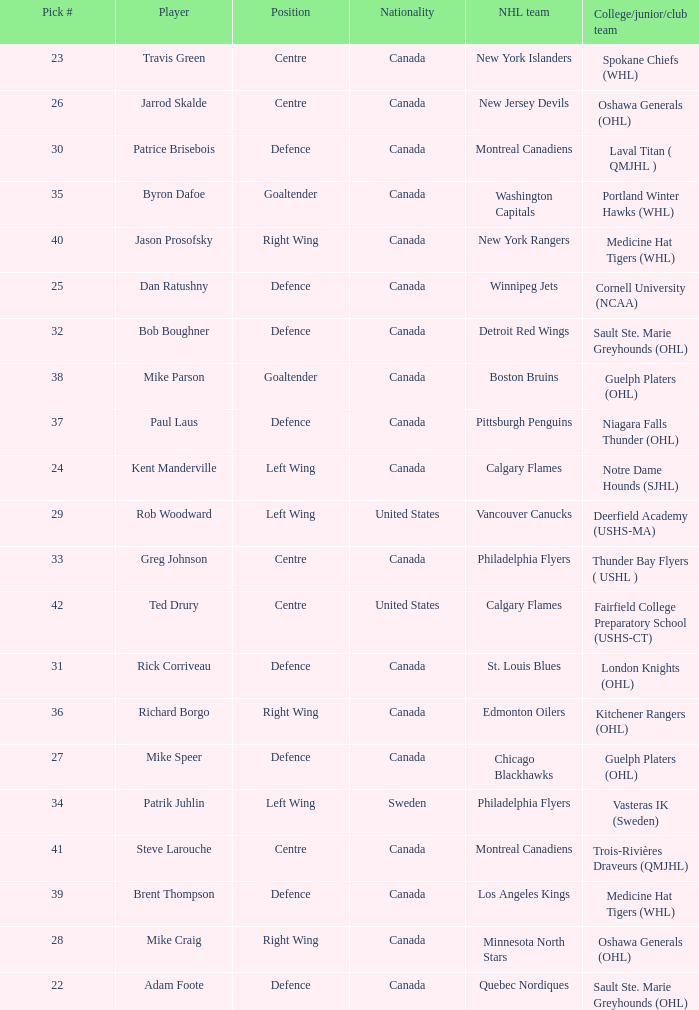What is the nationality of the player picked to go to Washington Capitals? Canada. 